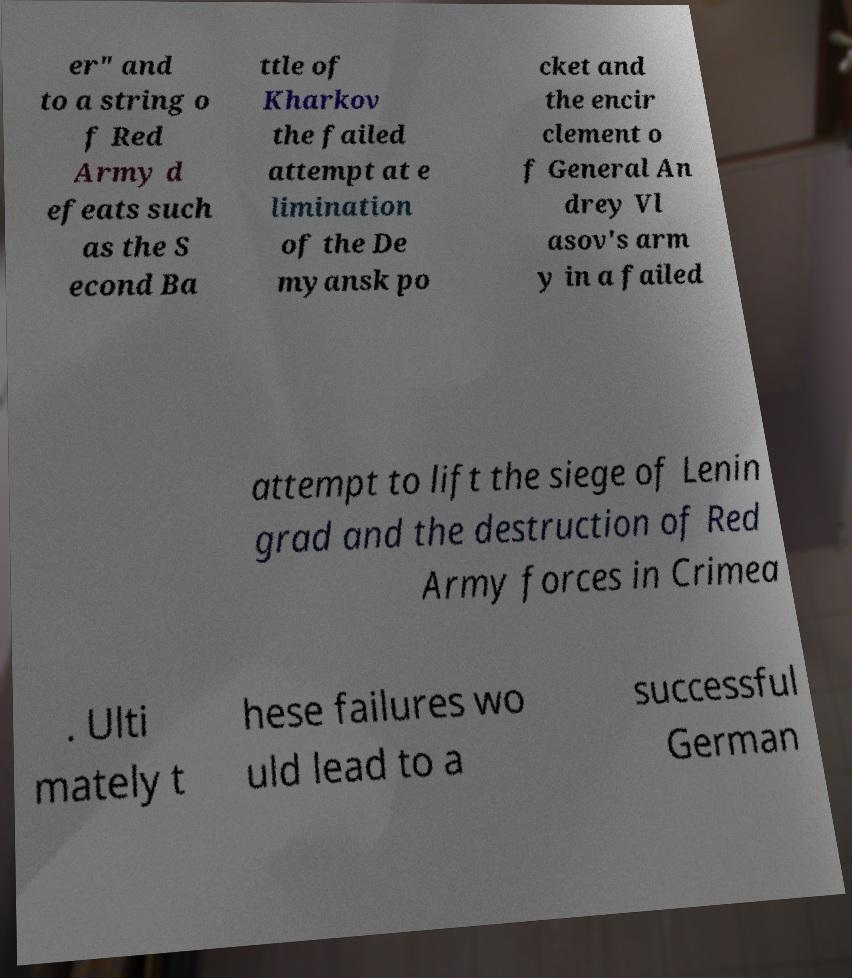Could you assist in decoding the text presented in this image and type it out clearly? er" and to a string o f Red Army d efeats such as the S econd Ba ttle of Kharkov the failed attempt at e limination of the De myansk po cket and the encir clement o f General An drey Vl asov's arm y in a failed attempt to lift the siege of Lenin grad and the destruction of Red Army forces in Crimea . Ulti mately t hese failures wo uld lead to a successful German 